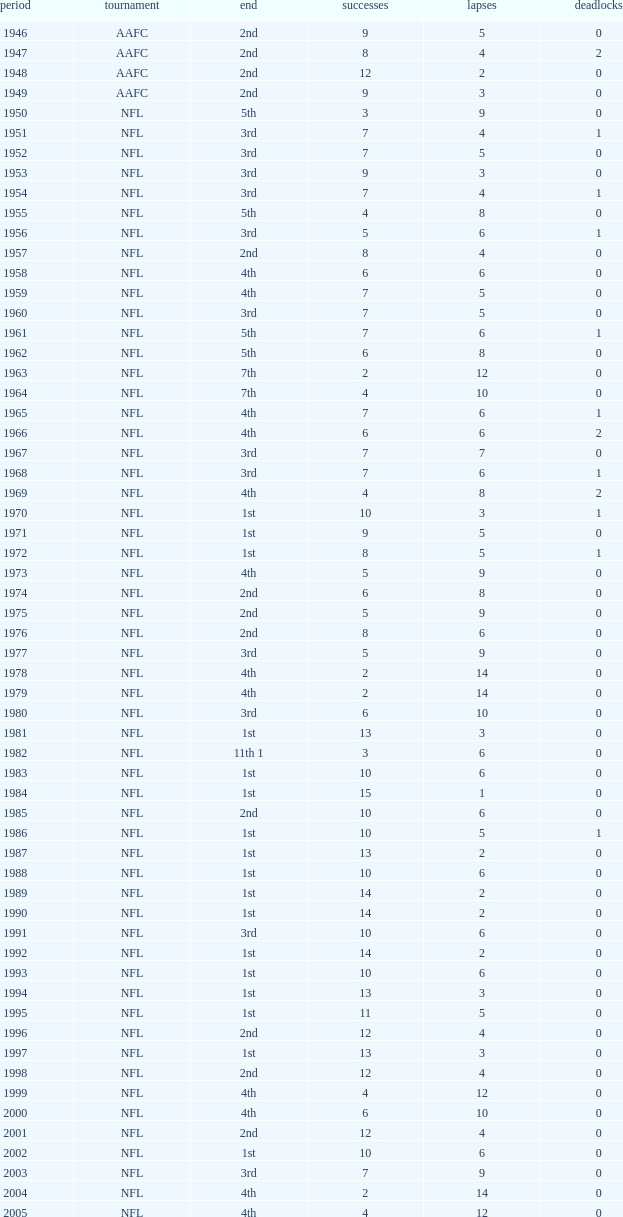Could you help me parse every detail presented in this table? {'header': ['period', 'tournament', 'end', 'successes', 'lapses', 'deadlocks'], 'rows': [['1946', 'AAFC', '2nd', '9', '5', '0'], ['1947', 'AAFC', '2nd', '8', '4', '2'], ['1948', 'AAFC', '2nd', '12', '2', '0'], ['1949', 'AAFC', '2nd', '9', '3', '0'], ['1950', 'NFL', '5th', '3', '9', '0'], ['1951', 'NFL', '3rd', '7', '4', '1'], ['1952', 'NFL', '3rd', '7', '5', '0'], ['1953', 'NFL', '3rd', '9', '3', '0'], ['1954', 'NFL', '3rd', '7', '4', '1'], ['1955', 'NFL', '5th', '4', '8', '0'], ['1956', 'NFL', '3rd', '5', '6', '1'], ['1957', 'NFL', '2nd', '8', '4', '0'], ['1958', 'NFL', '4th', '6', '6', '0'], ['1959', 'NFL', '4th', '7', '5', '0'], ['1960', 'NFL', '3rd', '7', '5', '0'], ['1961', 'NFL', '5th', '7', '6', '1'], ['1962', 'NFL', '5th', '6', '8', '0'], ['1963', 'NFL', '7th', '2', '12', '0'], ['1964', 'NFL', '7th', '4', '10', '0'], ['1965', 'NFL', '4th', '7', '6', '1'], ['1966', 'NFL', '4th', '6', '6', '2'], ['1967', 'NFL', '3rd', '7', '7', '0'], ['1968', 'NFL', '3rd', '7', '6', '1'], ['1969', 'NFL', '4th', '4', '8', '2'], ['1970', 'NFL', '1st', '10', '3', '1'], ['1971', 'NFL', '1st', '9', '5', '0'], ['1972', 'NFL', '1st', '8', '5', '1'], ['1973', 'NFL', '4th', '5', '9', '0'], ['1974', 'NFL', '2nd', '6', '8', '0'], ['1975', 'NFL', '2nd', '5', '9', '0'], ['1976', 'NFL', '2nd', '8', '6', '0'], ['1977', 'NFL', '3rd', '5', '9', '0'], ['1978', 'NFL', '4th', '2', '14', '0'], ['1979', 'NFL', '4th', '2', '14', '0'], ['1980', 'NFL', '3rd', '6', '10', '0'], ['1981', 'NFL', '1st', '13', '3', '0'], ['1982', 'NFL', '11th 1', '3', '6', '0'], ['1983', 'NFL', '1st', '10', '6', '0'], ['1984', 'NFL', '1st', '15', '1', '0'], ['1985', 'NFL', '2nd', '10', '6', '0'], ['1986', 'NFL', '1st', '10', '5', '1'], ['1987', 'NFL', '1st', '13', '2', '0'], ['1988', 'NFL', '1st', '10', '6', '0'], ['1989', 'NFL', '1st', '14', '2', '0'], ['1990', 'NFL', '1st', '14', '2', '0'], ['1991', 'NFL', '3rd', '10', '6', '0'], ['1992', 'NFL', '1st', '14', '2', '0'], ['1993', 'NFL', '1st', '10', '6', '0'], ['1994', 'NFL', '1st', '13', '3', '0'], ['1995', 'NFL', '1st', '11', '5', '0'], ['1996', 'NFL', '2nd', '12', '4', '0'], ['1997', 'NFL', '1st', '13', '3', '0'], ['1998', 'NFL', '2nd', '12', '4', '0'], ['1999', 'NFL', '4th', '4', '12', '0'], ['2000', 'NFL', '4th', '6', '10', '0'], ['2001', 'NFL', '2nd', '12', '4', '0'], ['2002', 'NFL', '1st', '10', '6', '0'], ['2003', 'NFL', '3rd', '7', '9', '0'], ['2004', 'NFL', '4th', '2', '14', '0'], ['2005', 'NFL', '4th', '4', '12', '0'], ['2006', 'NFL', '3rd', '7', '9', '0'], ['2007', 'NFL', '3rd', '5', '11', '0'], ['2008', 'NFL', '2nd', '7', '9', '0'], ['2009', 'NFL', '2nd', '8', '8', '0'], ['2010', 'NFL', '3rd', '6', '10', '0'], ['2011', 'NFL', '1st', '13', '3', '0'], ['2012', 'NFL', '1st', '11', '4', '1'], ['2013', 'NFL', '2nd', '6', '2', '0']]} What is the losses in the NFL in the 2011 season with less than 13 wins? None. 